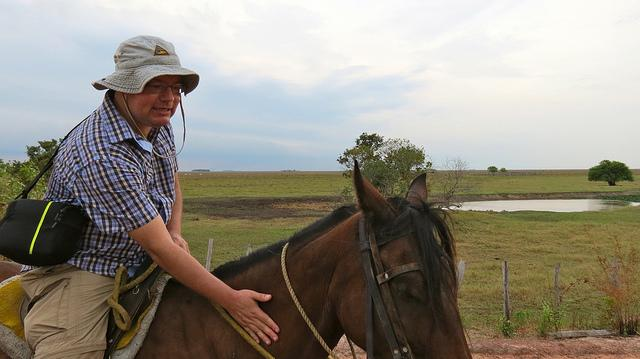What is the man trying to do to the horse? calm it 